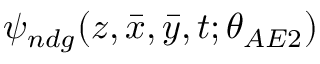<formula> <loc_0><loc_0><loc_500><loc_500>\psi _ { n d g } ( z , \bar { x } , \bar { y } , t ; \theta _ { A E 2 } )</formula> 